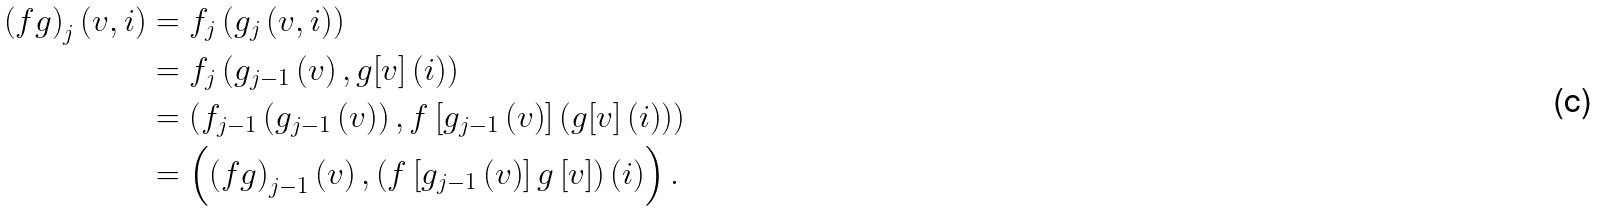Convert formula to latex. <formula><loc_0><loc_0><loc_500><loc_500>\left ( f g \right ) _ { j } \left ( v , i \right ) & = f _ { j } \left ( g _ { j } \left ( v , i \right ) \right ) \\ & = f _ { j } \left ( g _ { j - 1 } \left ( v \right ) , g [ v ] \left ( i \right ) \right ) \\ & = \left ( f _ { j - 1 } \left ( g _ { j - 1 } \left ( v \right ) \right ) , f \left [ g _ { j - 1 } \left ( v \right ) \right ] \left ( g [ v ] \left ( i \right ) \right ) \right ) \\ & = \left ( \left ( f g \right ) _ { j - 1 } \left ( v \right ) , \left ( f \left [ g _ { j - 1 } \left ( v \right ) \right ] g \left [ v \right ] \right ) \left ( i \right ) \right ) .</formula> 